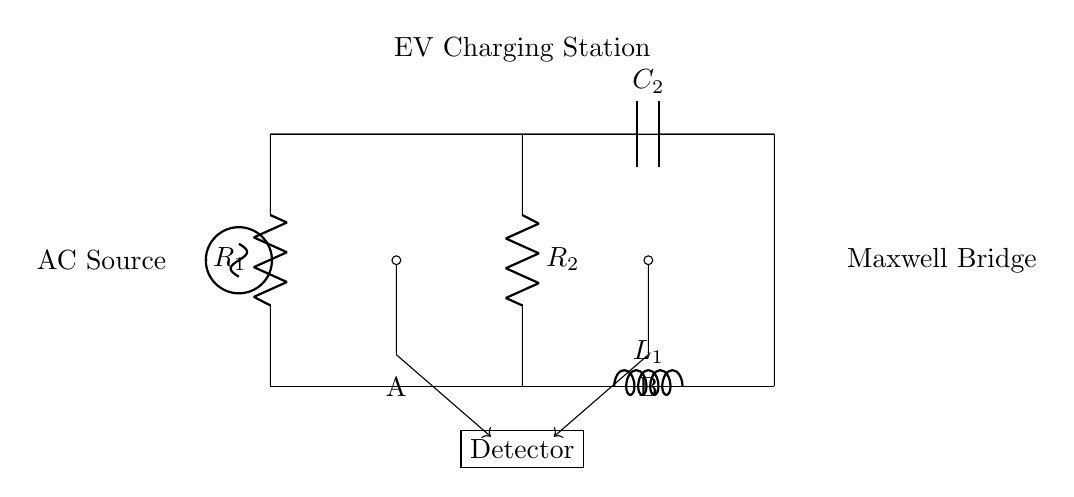What type of circuit is illustrated? The circuit is a Maxwell bridge, which is used for measuring the inductance of an inductor in this configuration. It is identified by the arrangement of resistors, capacitors, and an inductor connecting to a detector and an AC source.
Answer: Maxwell bridge What does the component labeled R1 represent? The component labeled R1 is a resistor, specifically one of the resistors used in the Maxwell bridge circuit. Resistors in this configuration help balance the bridge and allow for the accurate measurement of inductance.
Answer: Resistor How many capacitors are present in the circuit? There is one capacitor shown in the circuit diagram. Capacitors are important in this type of bridge for balancing the circuit and aiding in the measurement process.
Answer: One What is the function of the detector? The detector measures the output signal of the circuit, allowing for the determination of the inductance based on the balance achieved in the Maxwell bridge. It indicates whether the bridge is balanced or unbalanced.
Answer: Measurement Which component is used to measure inductance? The inductor labeled L1 is used to measure inductance in the bridge configuration. The measurement relies on balancing the circuit with resistors and capacitors, which allows the inductance to be determined accurately.
Answer: Inductor What is the role of the AC source in this circuit? The AC source provides the necessary alternating current that energizes the circuit, allowing for the measurements of the inductance to take place. It is crucial for the operation of the Maxwell bridge.
Answer: Power supply 